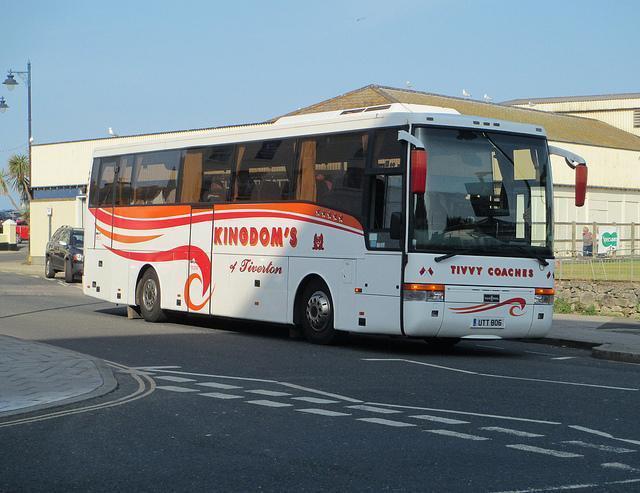How many candles on the cake are not lit?
Give a very brief answer. 0. 